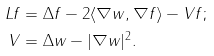<formula> <loc_0><loc_0><loc_500><loc_500>L f & = \Delta f - 2 \langle \nabla w , \nabla f \rangle - V f ; \\ V & = \Delta w - | \nabla w | ^ { 2 } .</formula> 